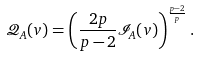<formula> <loc_0><loc_0><loc_500><loc_500>\mathcal { Q } _ { A } ( v ) = \left ( \frac { 2 p } { p - 2 } \mathcal { I } _ { A } ( v ) \right ) ^ { \frac { p - 2 } { p } } .</formula> 